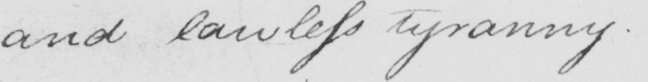Can you tell me what this handwritten text says? and lawless tyranny .  _ 